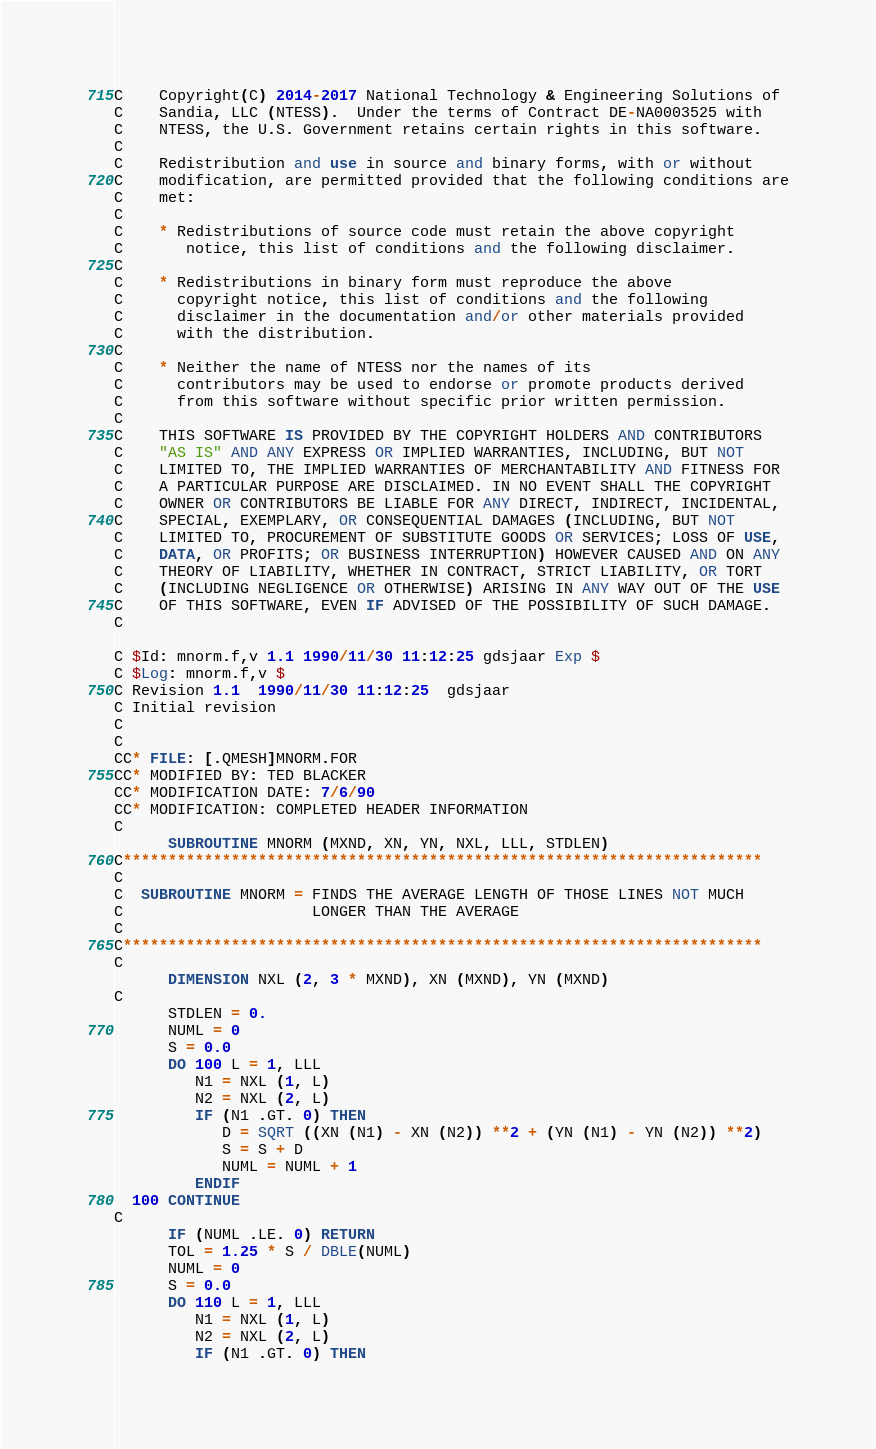<code> <loc_0><loc_0><loc_500><loc_500><_FORTRAN_>C    Copyright(C) 2014-2017 National Technology & Engineering Solutions of
C    Sandia, LLC (NTESS).  Under the terms of Contract DE-NA0003525 with
C    NTESS, the U.S. Government retains certain rights in this software.
C
C    Redistribution and use in source and binary forms, with or without
C    modification, are permitted provided that the following conditions are
C    met:
C
C    * Redistributions of source code must retain the above copyright
C       notice, this list of conditions and the following disclaimer.
C
C    * Redistributions in binary form must reproduce the above
C      copyright notice, this list of conditions and the following
C      disclaimer in the documentation and/or other materials provided
C      with the distribution.
C
C    * Neither the name of NTESS nor the names of its
C      contributors may be used to endorse or promote products derived
C      from this software without specific prior written permission.
C
C    THIS SOFTWARE IS PROVIDED BY THE COPYRIGHT HOLDERS AND CONTRIBUTORS
C    "AS IS" AND ANY EXPRESS OR IMPLIED WARRANTIES, INCLUDING, BUT NOT
C    LIMITED TO, THE IMPLIED WARRANTIES OF MERCHANTABILITY AND FITNESS FOR
C    A PARTICULAR PURPOSE ARE DISCLAIMED. IN NO EVENT SHALL THE COPYRIGHT
C    OWNER OR CONTRIBUTORS BE LIABLE FOR ANY DIRECT, INDIRECT, INCIDENTAL,
C    SPECIAL, EXEMPLARY, OR CONSEQUENTIAL DAMAGES (INCLUDING, BUT NOT
C    LIMITED TO, PROCUREMENT OF SUBSTITUTE GOODS OR SERVICES; LOSS OF USE,
C    DATA, OR PROFITS; OR BUSINESS INTERRUPTION) HOWEVER CAUSED AND ON ANY
C    THEORY OF LIABILITY, WHETHER IN CONTRACT, STRICT LIABILITY, OR TORT
C    (INCLUDING NEGLIGENCE OR OTHERWISE) ARISING IN ANY WAY OUT OF THE USE
C    OF THIS SOFTWARE, EVEN IF ADVISED OF THE POSSIBILITY OF SUCH DAMAGE.
C

C $Id: mnorm.f,v 1.1 1990/11/30 11:12:25 gdsjaar Exp $
C $Log: mnorm.f,v $
C Revision 1.1  1990/11/30 11:12:25  gdsjaar
C Initial revision
C
C
CC* FILE: [.QMESH]MNORM.FOR
CC* MODIFIED BY: TED BLACKER
CC* MODIFICATION DATE: 7/6/90
CC* MODIFICATION: COMPLETED HEADER INFORMATION
C
      SUBROUTINE MNORM (MXND, XN, YN, NXL, LLL, STDLEN)
C***********************************************************************
C
C  SUBROUTINE MNORM = FINDS THE AVERAGE LENGTH OF THOSE LINES NOT MUCH
C                     LONGER THAN THE AVERAGE
C
C***********************************************************************
C
      DIMENSION NXL (2, 3 * MXND), XN (MXND), YN (MXND)
C
      STDLEN = 0.
      NUML = 0
      S = 0.0
      DO 100 L = 1, LLL
         N1 = NXL (1, L)
         N2 = NXL (2, L)
         IF (N1 .GT. 0) THEN
            D = SQRT ((XN (N1) - XN (N2)) **2 + (YN (N1) - YN (N2)) **2)
            S = S + D
            NUML = NUML + 1
         ENDIF
  100 CONTINUE
C
      IF (NUML .LE. 0) RETURN
      TOL = 1.25 * S / DBLE(NUML)
      NUML = 0
      S = 0.0
      DO 110 L = 1, LLL
         N1 = NXL (1, L)
         N2 = NXL (2, L)
         IF (N1 .GT. 0) THEN</code> 